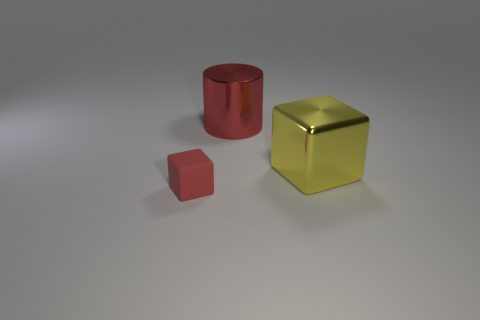There is a large red metal thing; are there any large metallic blocks to the left of it?
Ensure brevity in your answer.  No. There is a block that is the same color as the metal cylinder; what is it made of?
Offer a very short reply. Rubber. How many cylinders are either big gray metal things or matte objects?
Keep it short and to the point. 0. Does the red matte object have the same shape as the yellow metal thing?
Your response must be concise. Yes. What size is the cube that is to the right of the matte cube?
Keep it short and to the point. Large. Are there any metal things of the same color as the small rubber object?
Your response must be concise. Yes. Do the red object that is on the right side of the matte block and the rubber object have the same size?
Make the answer very short. No. What is the color of the small matte object?
Ensure brevity in your answer.  Red. There is a big metal object behind the cube that is behind the small red thing; what is its color?
Offer a terse response. Red. Is there a tiny red block made of the same material as the large yellow cube?
Give a very brief answer. No. 